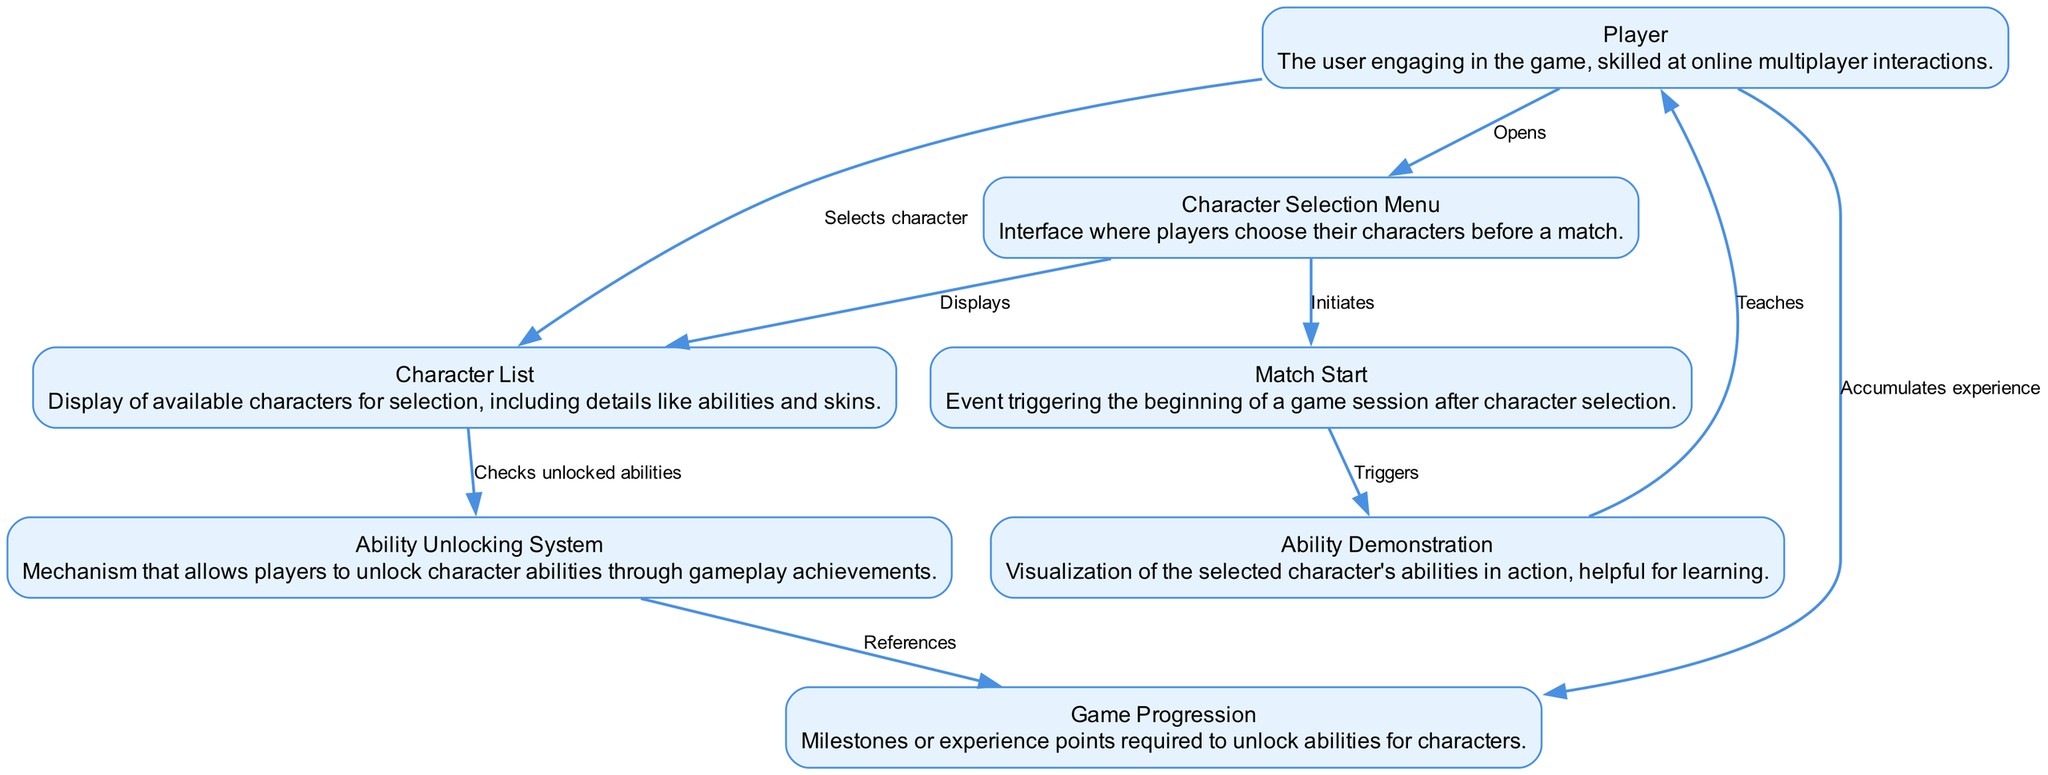What is the first action the player takes in the process? The first action represented in the diagram shows the player opening the character selection menu. This is the initial step before any character can be selected.
Answer: Opens How many nodes are present in the diagram? By counting each unique element represented in the diagram, including the player, selection menu, character list, ability system, progression, match start, and ability demonstration, we find a total of seven nodes.
Answer: Seven What does the character selection menu do after the player interacts with it? The character selection menu displays the character list for the player to choose from, indicating its role in presenting available characters.
Answer: Displays What action links the ability unlocking system to game progression? The action that connects the ability unlocking system to game progression is a reference check that determines how abilities correlate with the player's achievements.
Answer: References Which node represents the culmination of the character selection process? The culmination of the character selection process is represented by the match start, which occurs after the selection has been made.
Answer: Match Start After the match starts, what is triggered according to the diagram? Following the initiation of the match, an ability demonstration is triggered to show the player how the selected character's abilities work.
Answer: Triggers How does the player accumulate experience points? The player accumulates experience points through gameplay, which is reflected in the diagram as an ongoing process that enhances their ability unlocking potential.
Answer: Accumulates experience What does the ability demonstration do in relation to the player? The ability demonstration educates the player on how to utilize the selected character’s abilities effectively, forming a crucial part of the learning process.
Answer: Teaches What relationship exists between the character list and the player? The relationship illustrated in the diagram shows that the player selects a character from the character list, highlighting the interactive nature of this step.
Answer: Selects character 